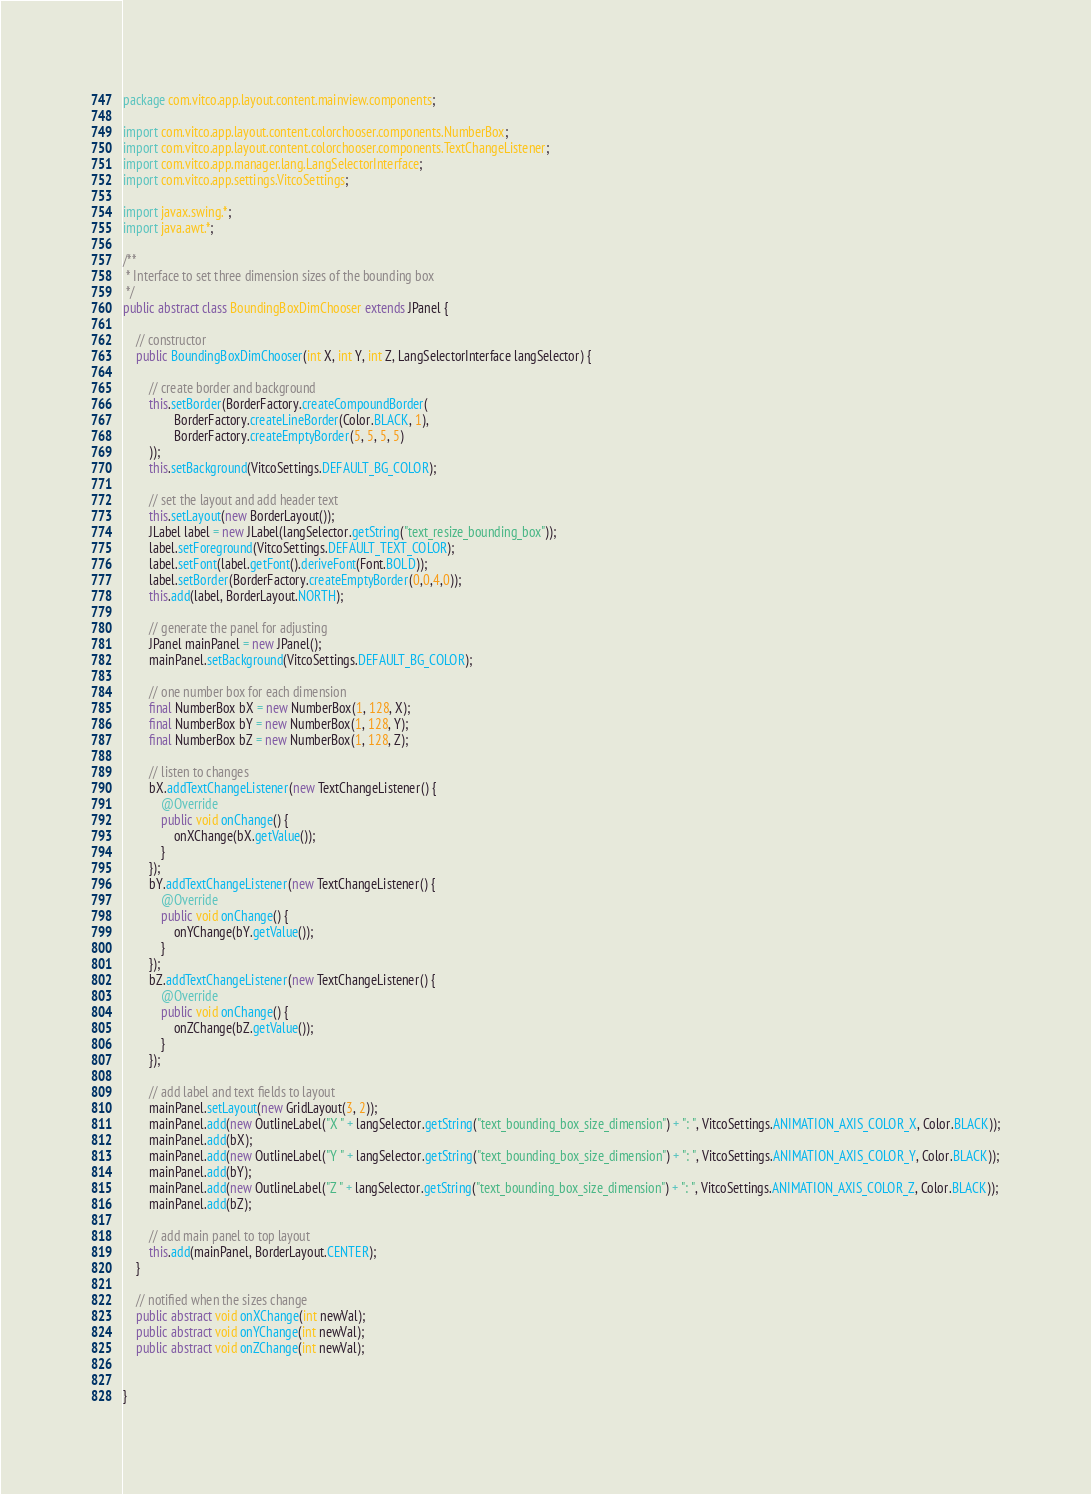<code> <loc_0><loc_0><loc_500><loc_500><_Java_>package com.vitco.app.layout.content.mainview.components;

import com.vitco.app.layout.content.colorchooser.components.NumberBox;
import com.vitco.app.layout.content.colorchooser.components.TextChangeListener;
import com.vitco.app.manager.lang.LangSelectorInterface;
import com.vitco.app.settings.VitcoSettings;

import javax.swing.*;
import java.awt.*;

/**
 * Interface to set three dimension sizes of the bounding box
 */
public abstract class BoundingBoxDimChooser extends JPanel {

    // constructor
    public BoundingBoxDimChooser(int X, int Y, int Z, LangSelectorInterface langSelector) {

        // create border and background
        this.setBorder(BorderFactory.createCompoundBorder(
                BorderFactory.createLineBorder(Color.BLACK, 1),
                BorderFactory.createEmptyBorder(5, 5, 5, 5)
        ));
        this.setBackground(VitcoSettings.DEFAULT_BG_COLOR);

        // set the layout and add header text
        this.setLayout(new BorderLayout());
        JLabel label = new JLabel(langSelector.getString("text_resize_bounding_box"));
        label.setForeground(VitcoSettings.DEFAULT_TEXT_COLOR);
        label.setFont(label.getFont().deriveFont(Font.BOLD));
        label.setBorder(BorderFactory.createEmptyBorder(0,0,4,0));
        this.add(label, BorderLayout.NORTH);

        // generate the panel for adjusting
        JPanel mainPanel = new JPanel();
        mainPanel.setBackground(VitcoSettings.DEFAULT_BG_COLOR);

        // one number box for each dimension
        final NumberBox bX = new NumberBox(1, 128, X);
        final NumberBox bY = new NumberBox(1, 128, Y);
        final NumberBox bZ = new NumberBox(1, 128, Z);

        // listen to changes
        bX.addTextChangeListener(new TextChangeListener() {
            @Override
            public void onChange() {
                onXChange(bX.getValue());
            }
        });
        bY.addTextChangeListener(new TextChangeListener() {
            @Override
            public void onChange() {
                onYChange(bY.getValue());
            }
        });
        bZ.addTextChangeListener(new TextChangeListener() {
            @Override
            public void onChange() {
                onZChange(bZ.getValue());
            }
        });

        // add label and text fields to layout
        mainPanel.setLayout(new GridLayout(3, 2));
        mainPanel.add(new OutlineLabel("X " + langSelector.getString("text_bounding_box_size_dimension") + ": ", VitcoSettings.ANIMATION_AXIS_COLOR_X, Color.BLACK));
        mainPanel.add(bX);
        mainPanel.add(new OutlineLabel("Y " + langSelector.getString("text_bounding_box_size_dimension") + ": ", VitcoSettings.ANIMATION_AXIS_COLOR_Y, Color.BLACK));
        mainPanel.add(bY);
        mainPanel.add(new OutlineLabel("Z " + langSelector.getString("text_bounding_box_size_dimension") + ": ", VitcoSettings.ANIMATION_AXIS_COLOR_Z, Color.BLACK));
        mainPanel.add(bZ);

        // add main panel to top layout
        this.add(mainPanel, BorderLayout.CENTER);
    }

    // notified when the sizes change
    public abstract void onXChange(int newVal);
    public abstract void onYChange(int newVal);
    public abstract void onZChange(int newVal);


}
</code> 